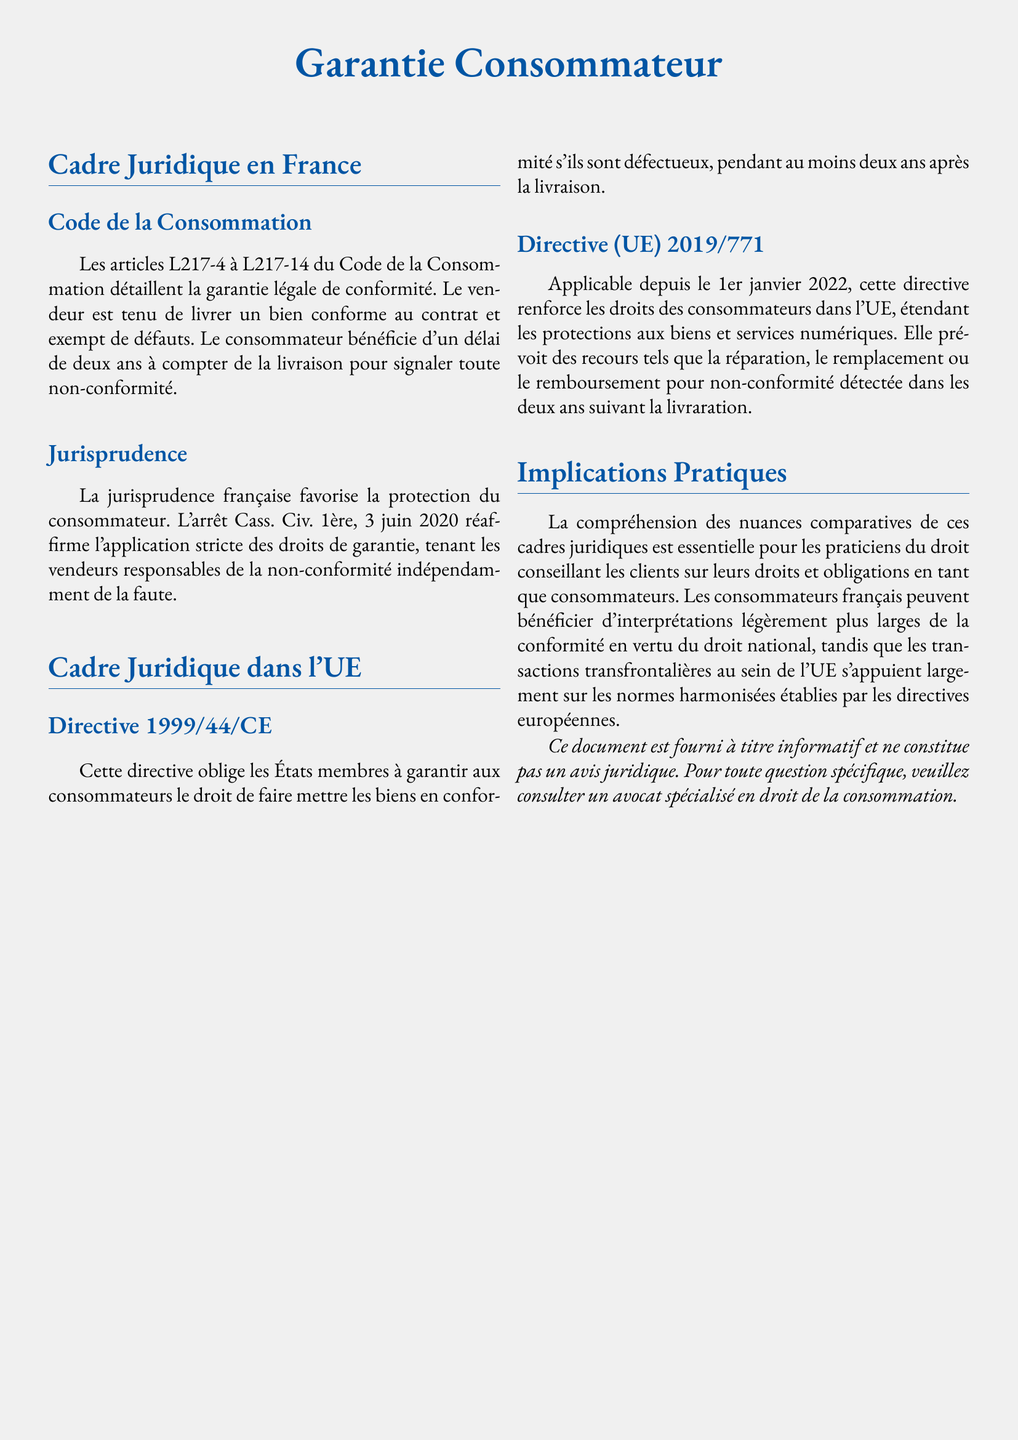Quel est l'article du Code de la Consommation qui traite de la garantie légale de conformité ? L'article mentionné dans le document est L217-4 à L217-14, qui détaille la garantie légale de conformité.
Answer: L217-4 à L217-14 Quel est le délai pour signaler une non-conformité en France ? Le document indique que le consommateur bénéficie d'un délai de deux ans à compter de la livraison pour signaler toute non-conformité.
Answer: Deux ans Quelle directive européenne établit les droits des consommateurs concernant la non-conformité des biens ? Le document mentionne la directive 1999/44/CE qui oblige les États membres à garantir ce droit.
Answer: Directive 1999/44/CE Quand la directive (UE) 2019/771 est-elle entrée en application ? Il est précisé dans le document que cette directive est applicable depuis le 1er janvier 2022.
Answer: 1er janvier 2022 Quelles options de recours sont offertes par la directive (UE) 2019/771 pour non-conformité ? Les recours mentionnés dans le document incluent la réparation, le remplacement ou le remboursement.
Answer: Réparation, remplacement, remboursement Quel est l'objectif principal de la compréhension des nuances comparatives évoquées dans le document ? Le document souligne que cette compréhension est essentielle pour les praticiens du droit conseillant les clients sur leurs droits et obligations.
Answer: Conseiller les clients Quel cas de jurisprudence est cité concernant les droits de garantie en France ? Le document fait référence à l'arrêt Cass. Civ. 1ère, 3 juin 2020, qui traite de l'application des droits de garantie.
Answer: Cass. Civ. 1ère, 3 juin 2020 Quelle est une des implications pratiques du droit de la consommation selon le document ? Il est mentionné que les consommateurs français peuvent bénéficier d'interprétations légèrement plus larges de la conformité.
Answer: Interprétations plus larges Quel est l'objectif de la directive (UE) 2019/771 par rapport aux biens numériques ? Le document précise qu'elle renforce les droits des consommateurs en étendant les protections aux biens et services numériques.
Answer: Renforcer les droits des consommateurs 